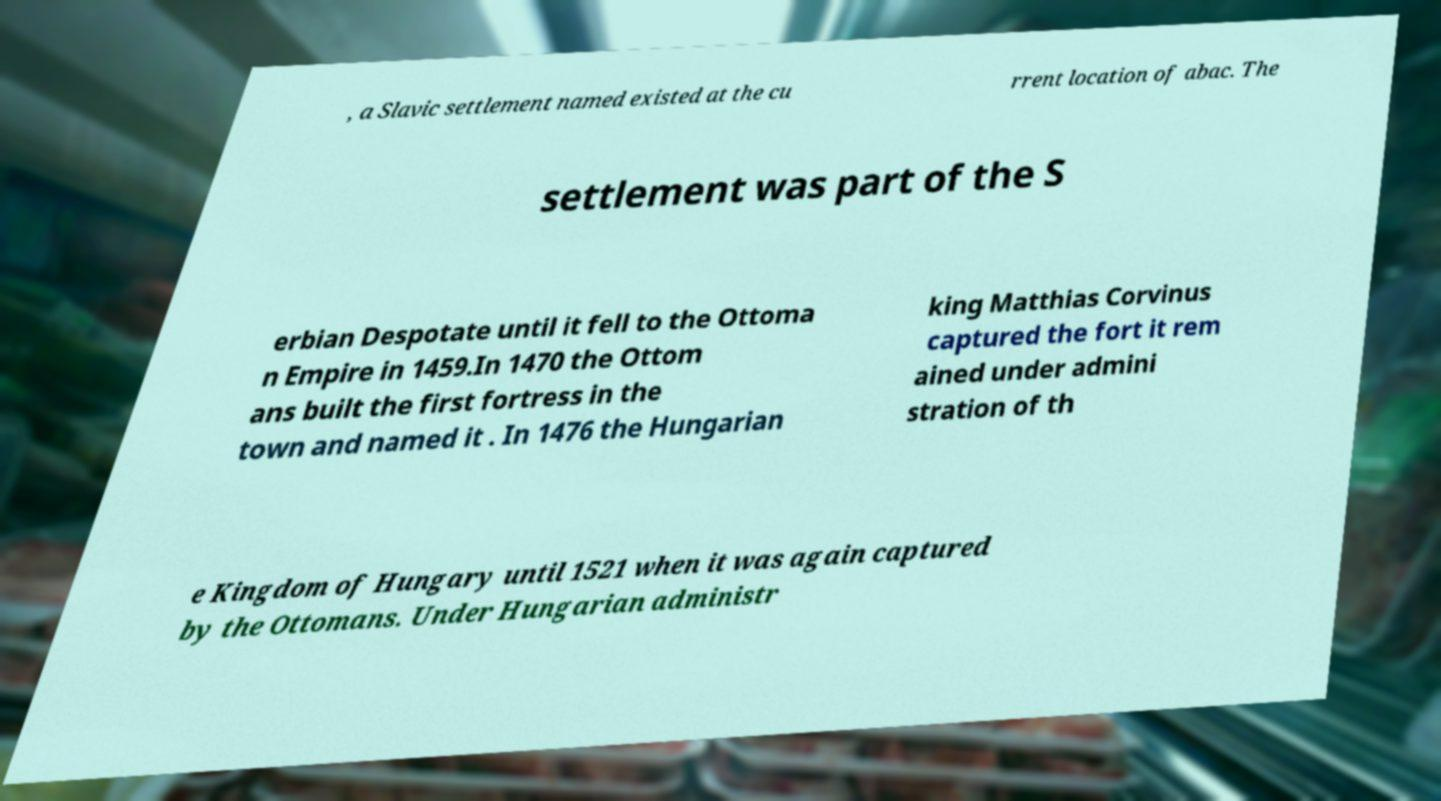Can you accurately transcribe the text from the provided image for me? , a Slavic settlement named existed at the cu rrent location of abac. The settlement was part of the S erbian Despotate until it fell to the Ottoma n Empire in 1459.In 1470 the Ottom ans built the first fortress in the town and named it . In 1476 the Hungarian king Matthias Corvinus captured the fort it rem ained under admini stration of th e Kingdom of Hungary until 1521 when it was again captured by the Ottomans. Under Hungarian administr 